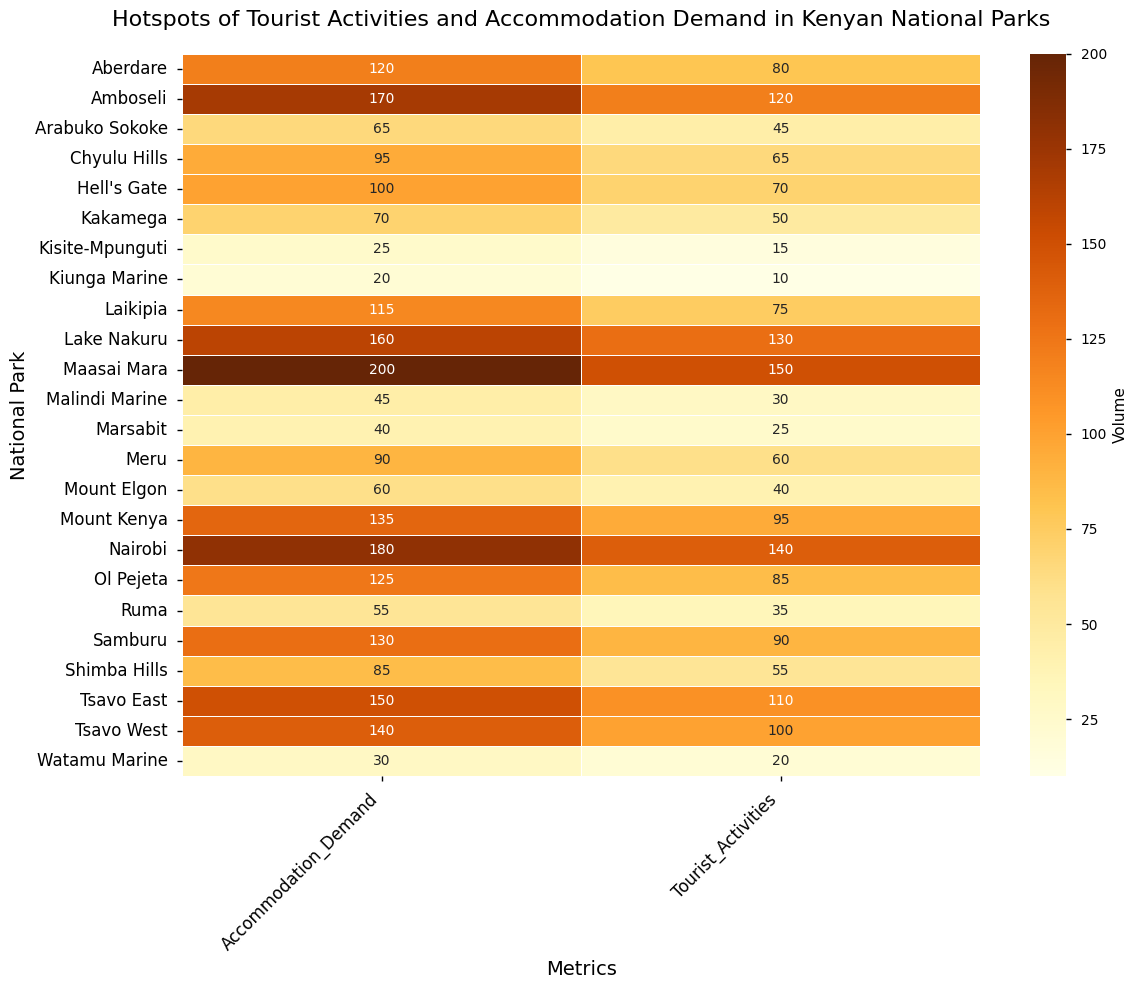Which national park has the highest demand for accommodation? The heatmap shows the Accommodation Demand values for each national park. By identifying the park with the darkest shade (highest value) in the "Accommodation Demand" column, which is Maasai Mara with 200.
Answer: Maasai Mara Which national park has the lowest number of tourist activities? The heatmap shows the Tourist Activities values for each national park. Identifying the park with the lightest shade (lowest value) in the "Tourist Activities" column, which is Kiunga Marine with 10.
Answer: Kiunga Marine Which national park has more tourist activities: Amboseli or Tsavo West? By comparing the Tourist Activities values of Amboseli and Tsavo West from the heatmap, Amboseli has 120 and Tsavo West has 100. Amboseli has more tourist activities.
Answer: Amboseli What is the difference between the accommodation demand in Nairobi National Park and Hell's Gate National Park? Nairobi National Park has an Accommodation Demand of 180, while Hell's Gate has 100. The difference is 180 - 100 = 80.
Answer: 80 Which park has a higher number of tourist activities: Mount Kenya or Samburu? From the heatmap, the Tourist Activities value for Mount Kenya is 95 and for Samburu is 90. Mount Kenya has a higher number of tourist activities.
Answer: Mount Kenya What is the sum of tourist activities in Lake Nakuru, Maasai Mara, and Amboseli National Parks? Lake Nakuru has 130, Maasai Mara has 150, and Amboseli has 120. Summing these values: 130 + 150 + 120 = 400.
Answer: 400 Which national park has a lower accommodation demand: Laikipia or Meru? The accommodation demand for Laikipia is 115, and for Meru, it is 90. Meru has a lower accommodation demand.
Answer: Meru What is the average accommodation demand across all national parks? Summing the accommodation demand values from all parks: 200 + 170 + 150 + 140 + 160 + 120 + 130 + 180 + 100 + 135 + 90 + 125 + 70 + 60 + 85 + 65 + 95 + 115 + 55 + 40 + 25 + 30 + 45 + 20 = 2320. Dividing by the number of parks (24), the average is 2320 / 24 ≈ 96.67.
Answer: ≈ 96.67 Which park has more accommodation demand: Tsavo East or Aberdare? By how much? Tsavo East has an Accommodation Demand of 150, and Aberdare has 120. The difference is 150 - 120 = 30.
Answer: Tsavo East by 30 